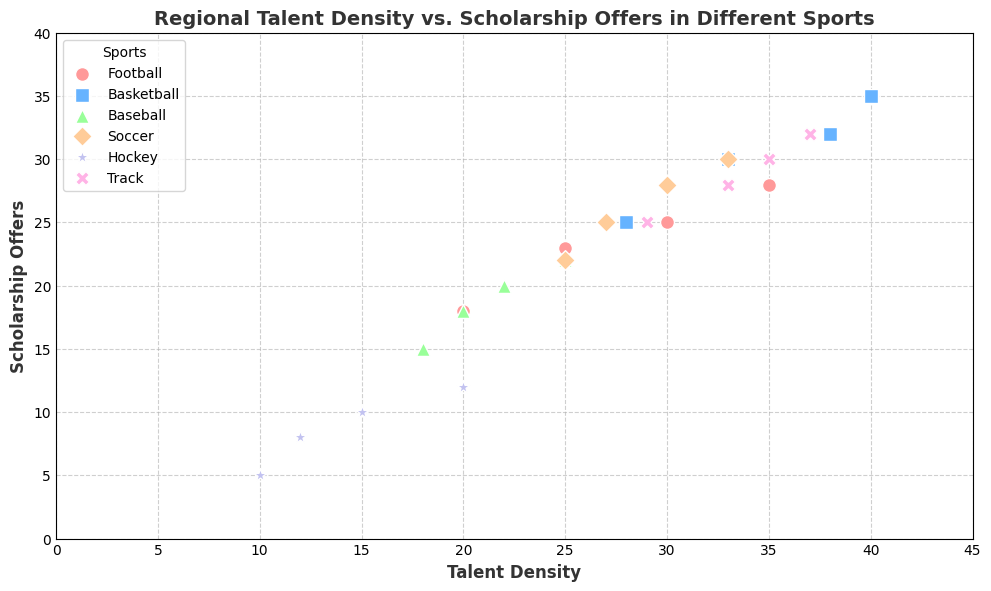What is the total number of scholarship offers for Track across all regions? To find the total number of scholarship offers for Track, sum the scholarship offers for Track in the East, West, North, and South regions. The offers are 30, 25, 28, and 32, respectively. Summing these up: 30 + 25 + 28 + 32 = 115
Answer: 115 Which sport in the East region has the highest Talent Density? Look at the Talent Density values for all sports in the East region. The values are Football: 30, Basketball: 40, Baseball: 22, Soccer: 30, Hockey: 15, and Track: 35. The highest value is 40, corresponding to Basketball.
Answer: Basketball Which region has the least scholarship offers for Hockey? Observe the scholarship offers for Hockey across all regions. The values are East: 10, West: 5, North: 12, and South: 8. The least value is 5, corresponding to the West region.
Answer: West What is the difference in Talent Density between Football and Soccer in the South region? Identify the Talent Density values for Football and Soccer in the South region. Football has a Talent Density of 35, and Soccer has a Talent Density of 33. The difference is 35 - 33 = 2
Answer: 2 Compare the Talent Density of Soccer in the North region with that of Baseball in the East region. Which one is higher? Look at the Talent Density values for Soccer in the North (27) and for Baseball in the East (22). 27 is greater than 22, so Soccer in the North region has a higher Talent Density.
Answer: Soccer in the North What are the visual attributes (color and marker) used to represent Basketball in the plot? Basketball is represented by a unique color and marker. By examining the visual attributes, we can see that Basketball is depicted using a blue color and a square marker.
Answer: Blue and square What is the combined Talent Density for Baseball across all regions? Add the Talent Density values for Baseball in the East, West, North, and South regions. The values are 22, 18, 20, and 25, respectively. 22 + 18 + 20 + 25 = 85
Answer: 85 Is the Talent Density of Hockey higher in the North region compared to the South region? Compare the Talent Density values for Hockey in the North and South regions. Hockey in the North has a Talent Density of 20, while in the South it is 12. Since 20 is greater than 12, it is higher in the North.
Answer: Yes What is the ratio of Soccer’s scholarship offers in the East region to Basketball’s scholarship offers in the same region? Identify Soccer’s scholarship offers (28) and Basketball’s scholarship offers (35) in the East region. The ratio is 28 to 35, or 28/35. Simplifying this fraction gives 4/5.
Answer: 4/5 